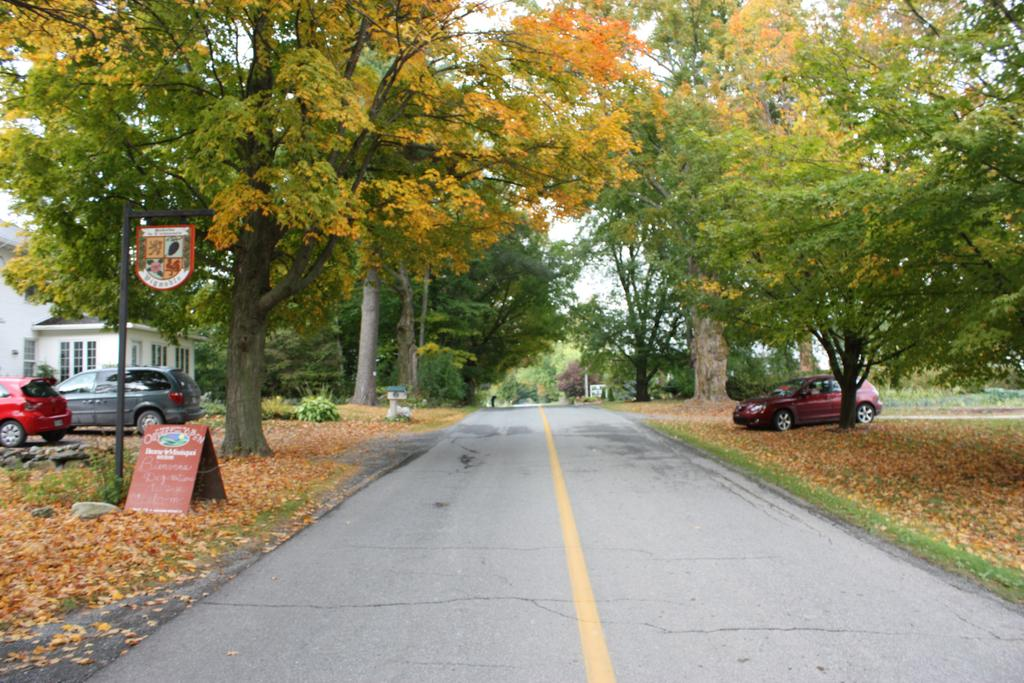What is the main feature of the image? There is a road in the image. What can be seen alongside the road? Trees are present alongside the road. What is happening on the road? Vehicles are visible on the road. What structure is located on the left side of the image? There is a building on the left side of the image. What else is present on the left side of the image? A pole and a board are present on the left side of the image. Where is the camp located in the image? There is no camp present in the image. What type of flock can be seen flying over the road in the image? There are no birds or flocks visible in the image. 